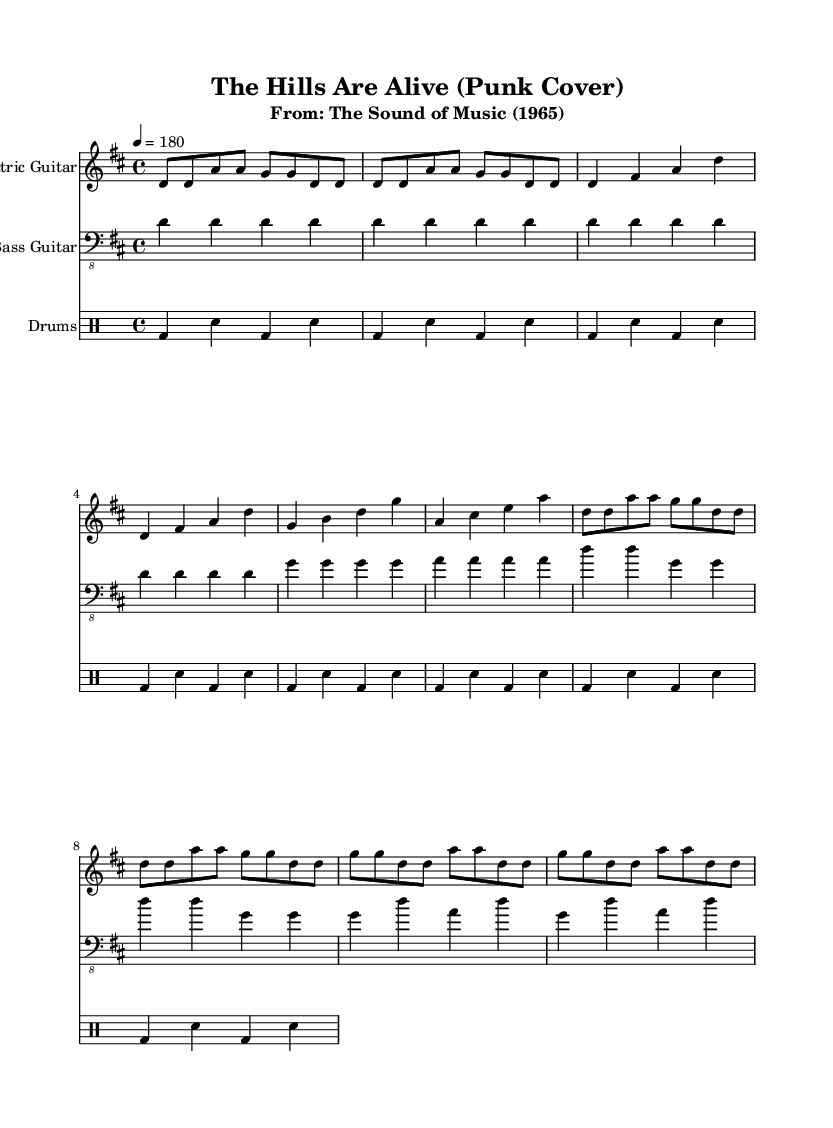What is the key signature of this music? The key signature is D major, which has two sharps (F# and C#).
Answer: D major What is the time signature of this music? The time signature is 4/4, indicating four beats per measure.
Answer: 4/4 What is the tempo marking of this piece? The tempo marking indicates a speed of 180 beats per minute.
Answer: 180 How many measures are there in the intro section? The intro consists of two measures. Each measure is clearly marked and counted separately.
Answer: 2 What is the rhythmic pattern used in the drums section? The drums use a basic punk beat pattern of bass drum and snare alternating every beat.
Answer: Bass drum and snare In which section does the bass guitar play the note G? The bass guitar plays the note G in both the verse and chorus sections of the music. This can be observed in the measures of those sections.
Answer: Verse and chorus What is the overall feel of the piece, based on its genre and tempo? The piece has a fast-paced, energetic feel typical of punk music, characterized by its upbeat tempo.
Answer: Energetic 